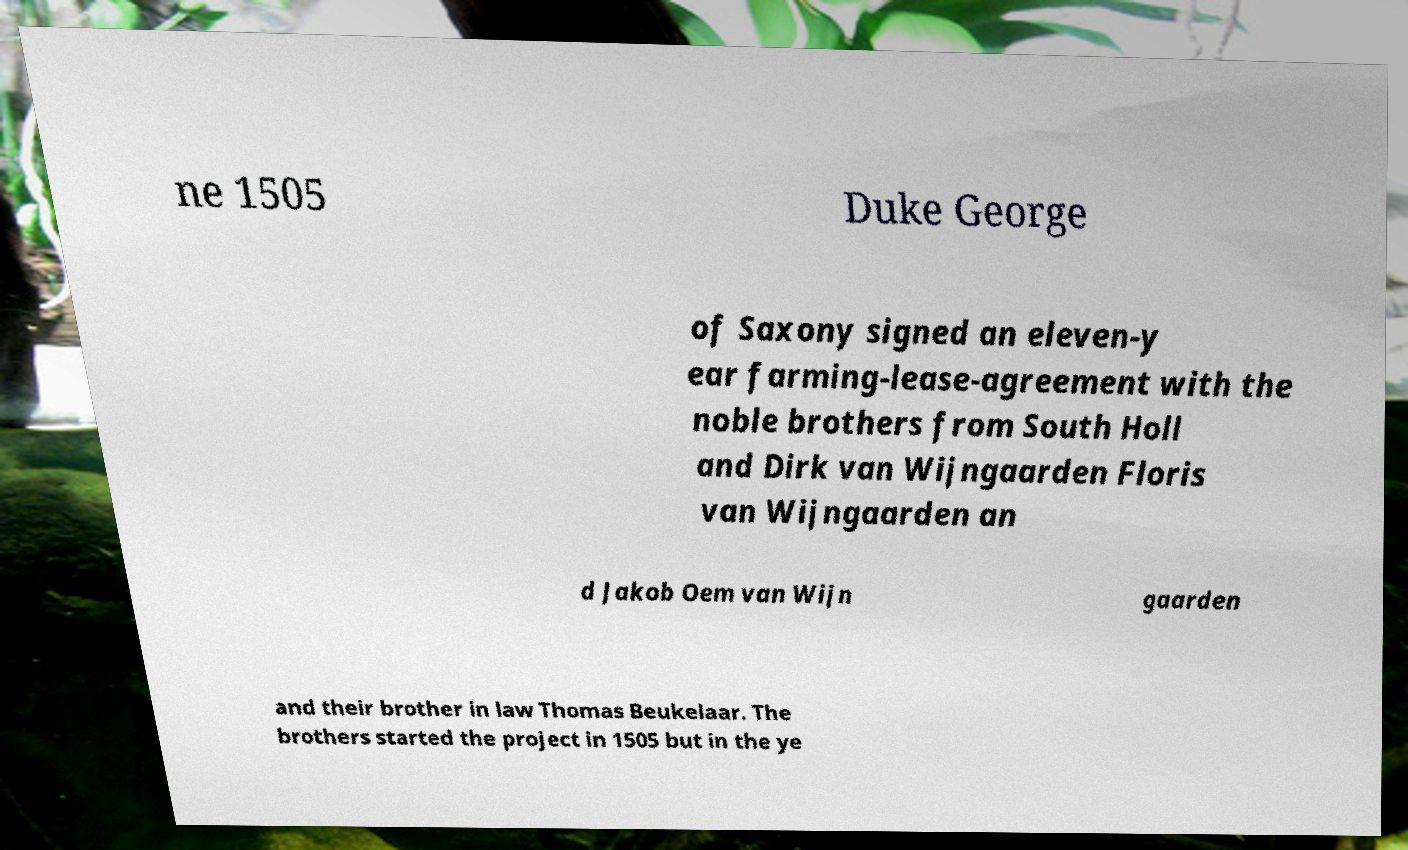For documentation purposes, I need the text within this image transcribed. Could you provide that? ne 1505 Duke George of Saxony signed an eleven-y ear farming-lease-agreement with the noble brothers from South Holl and Dirk van Wijngaarden Floris van Wijngaarden an d Jakob Oem van Wijn gaarden and their brother in law Thomas Beukelaar. The brothers started the project in 1505 but in the ye 